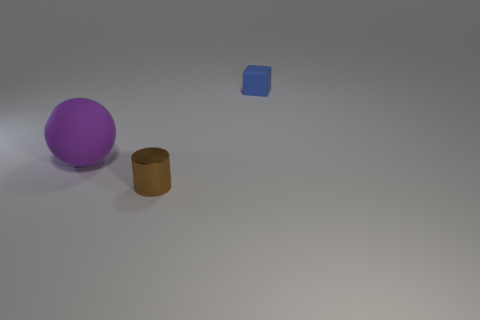Is there another big purple thing that has the same material as the purple object?
Offer a very short reply. No. Is the material of the tiny thing that is on the right side of the metallic cylinder the same as the tiny thing in front of the blue thing?
Provide a short and direct response. No. Is the number of tiny blocks left of the small brown metal object the same as the number of small blue things that are behind the small block?
Your response must be concise. Yes. What is the color of the cylinder that is the same size as the matte cube?
Keep it short and to the point. Brown. Is there a matte sphere of the same color as the tiny metallic object?
Give a very brief answer. No. What number of objects are cubes to the right of the cylinder or small blue cubes?
Provide a short and direct response. 1. What number of other objects are the same size as the cylinder?
Your response must be concise. 1. What material is the tiny object in front of the tiny thing on the right side of the thing in front of the big purple object?
Offer a very short reply. Metal. How many cubes are either blue metal objects or tiny brown things?
Your response must be concise. 0. Is there anything else that is the same shape as the metal object?
Your response must be concise. No. 